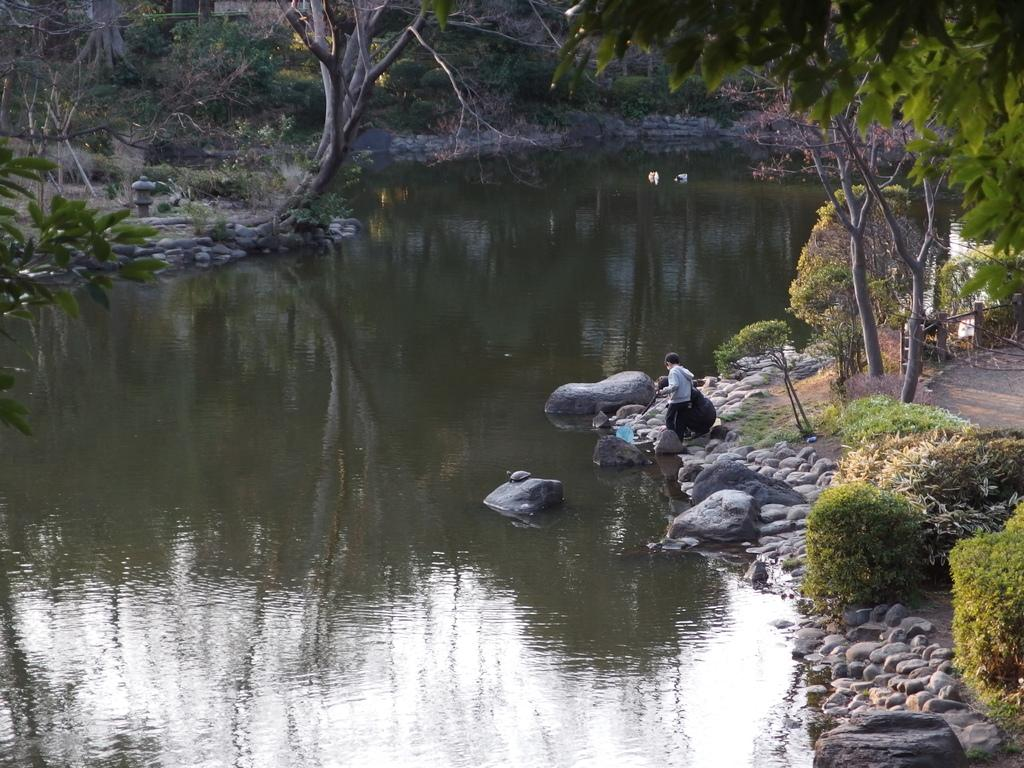What is the primary element visible in the image? There is water in the image. What type of natural features can be seen in the image? There are trees, plants, and rocks in the image. What is the man in the image doing? The man is standing on a rock in the image. What country is the actor attending school in the image? There is no country, actor, or school present in the image. 